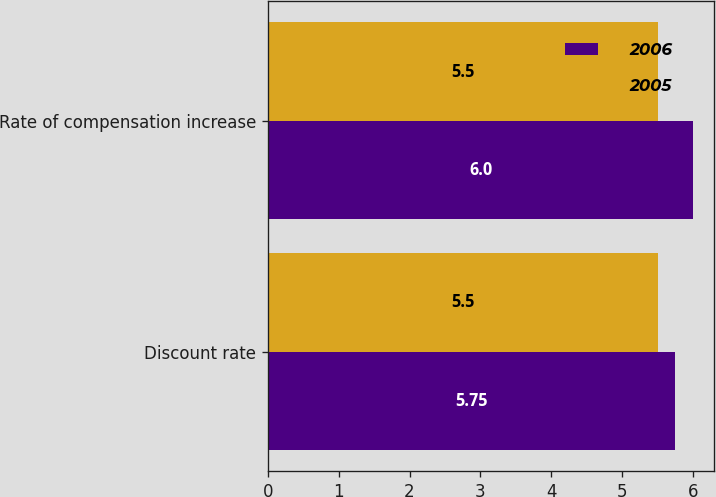Convert chart to OTSL. <chart><loc_0><loc_0><loc_500><loc_500><stacked_bar_chart><ecel><fcel>Discount rate<fcel>Rate of compensation increase<nl><fcel>2006<fcel>5.75<fcel>6<nl><fcel>2005<fcel>5.5<fcel>5.5<nl></chart> 